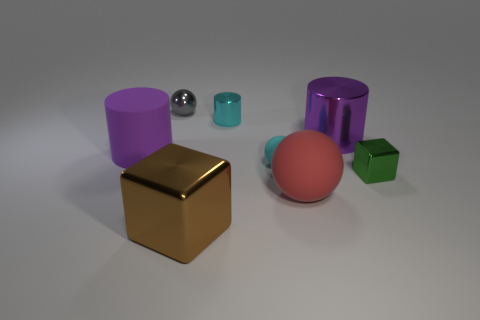There is a metal block that is in front of the small block; is there a cyan matte object that is behind it?
Your answer should be very brief. Yes. Is there any other thing that has the same shape as the small cyan matte thing?
Provide a short and direct response. Yes. Is the cyan cylinder the same size as the red rubber ball?
Provide a short and direct response. No. There is a big thing that is behind the thing left of the tiny gray ball that is left of the cyan metal cylinder; what is it made of?
Offer a terse response. Metal. Is the number of tiny blocks that are behind the small green block the same as the number of tiny green cubes?
Give a very brief answer. No. Is there anything else that has the same size as the brown metallic block?
Keep it short and to the point. Yes. What number of objects are either big rubber cylinders or balls?
Ensure brevity in your answer.  4. What shape is the large thing that is made of the same material as the big block?
Ensure brevity in your answer.  Cylinder. What is the size of the purple object that is behind the matte thing that is to the left of the cyan sphere?
Ensure brevity in your answer.  Large. How many small things are either yellow metal spheres or brown metal things?
Offer a very short reply. 0. 